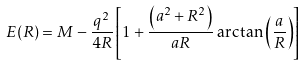Convert formula to latex. <formula><loc_0><loc_0><loc_500><loc_500>E ( R ) = M - \frac { q ^ { 2 } } { 4 R } \left [ 1 + \frac { \left ( a ^ { 2 } + R ^ { 2 } \right ) } { a R } \arctan \left ( \frac { a } { R } \right ) \right ]</formula> 